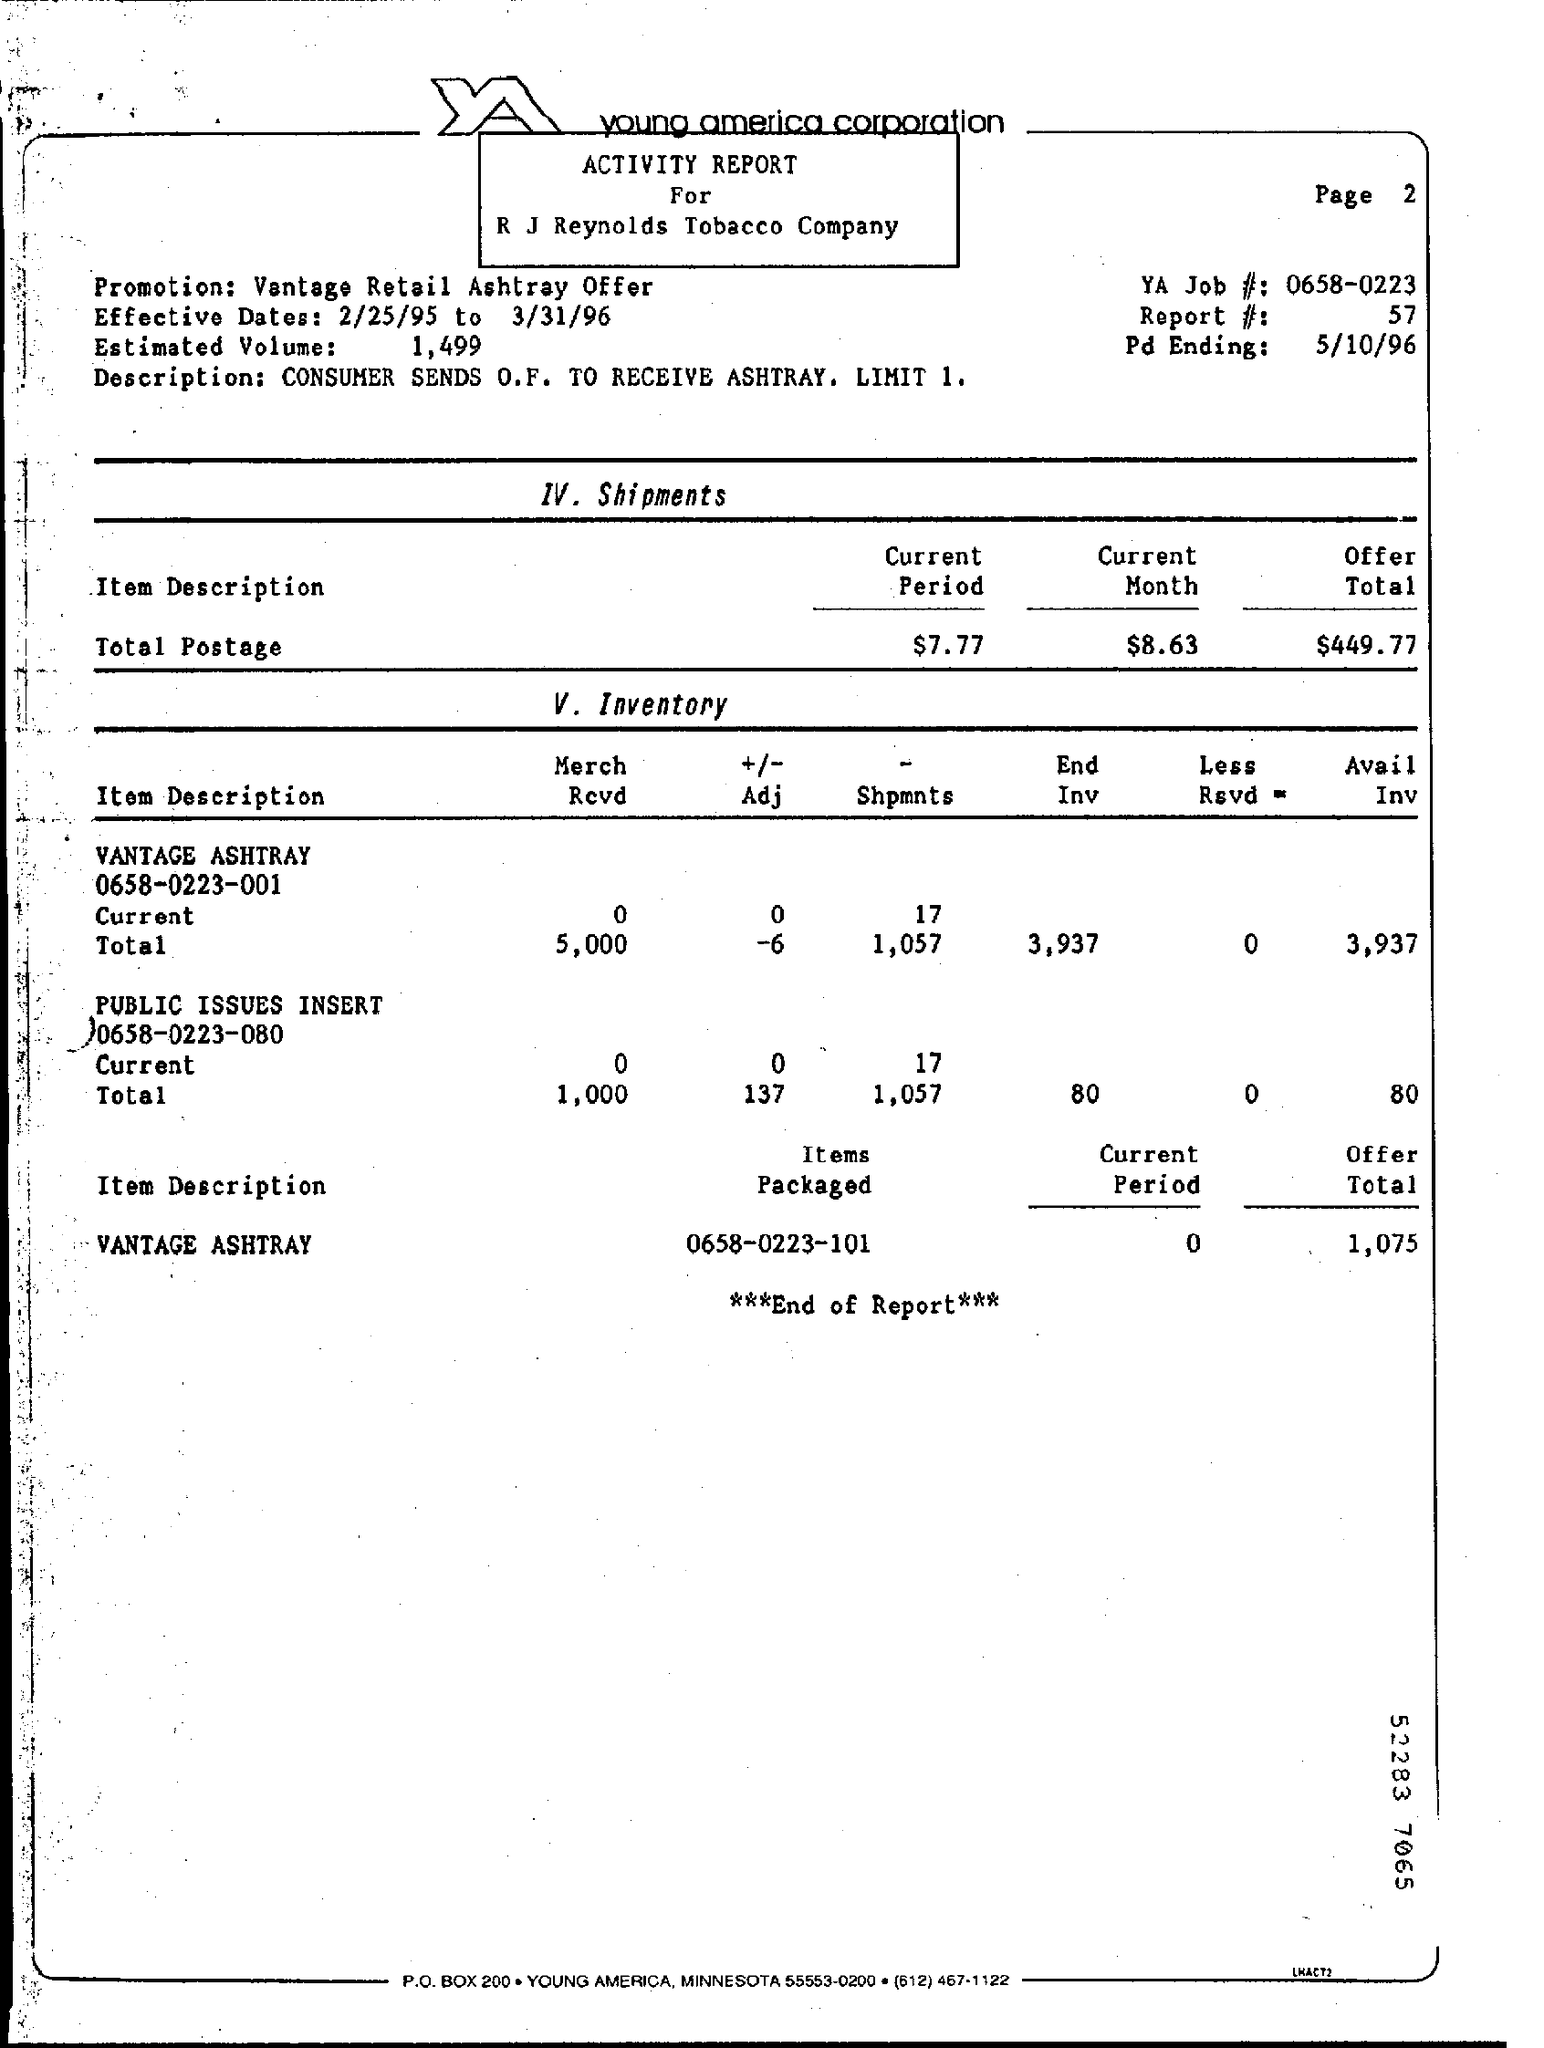What is the Promotion?
Provide a short and direct response. Vantage Retail Ashtray Offer. What are the Effective Dates?
Your answer should be compact. 2/25/95 TO 3/31/96. What is the Estimated Volume?
Ensure brevity in your answer.  1,499. What is the YA Job #?
Offer a terse response. 0658-0223. What is the Report#?
Keep it short and to the point. 57. What is the Pd Ending?
Keep it short and to the point. 5/10/96. What is the Offer Total for Vantage Ashtray?
Offer a very short reply. 1,075. 